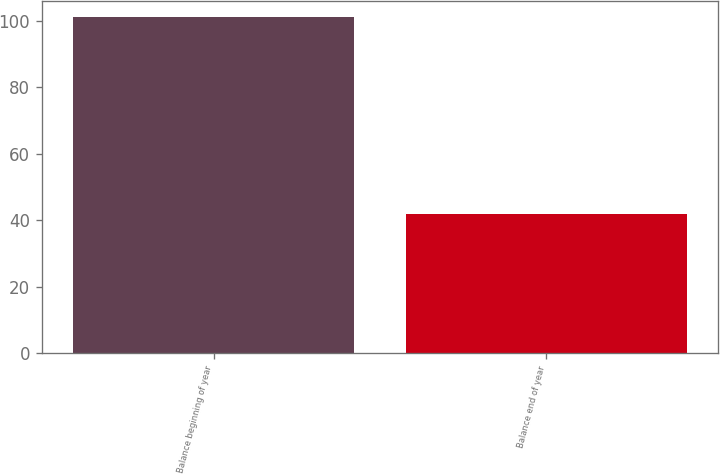Convert chart to OTSL. <chart><loc_0><loc_0><loc_500><loc_500><bar_chart><fcel>Balance beginning of year<fcel>Balance end of year<nl><fcel>101<fcel>42<nl></chart> 